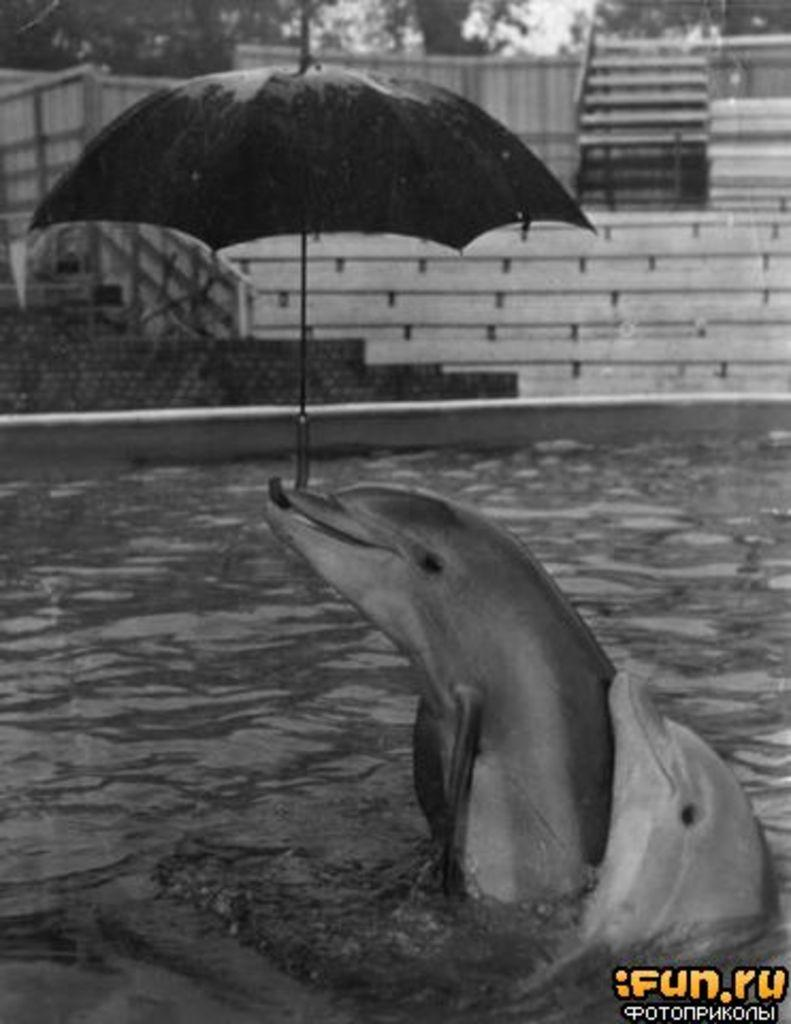What animal is in the image? There is a dolphin in the image. Where is the dolphin located? The dolphin is in the water. What unusual item does the dolphin have? The dolphin has an umbrella. What architectural feature can be seen in the background of the image? There are stairs visible in the background of the image. What type of patch can be seen on the dolphin's fin in the image? There is no patch visible on the dolphin's fin in the image. What type of fork is the dolphin using to eat in the image? Dolphins do not use forks to eat, and there is no fork present in the image. 